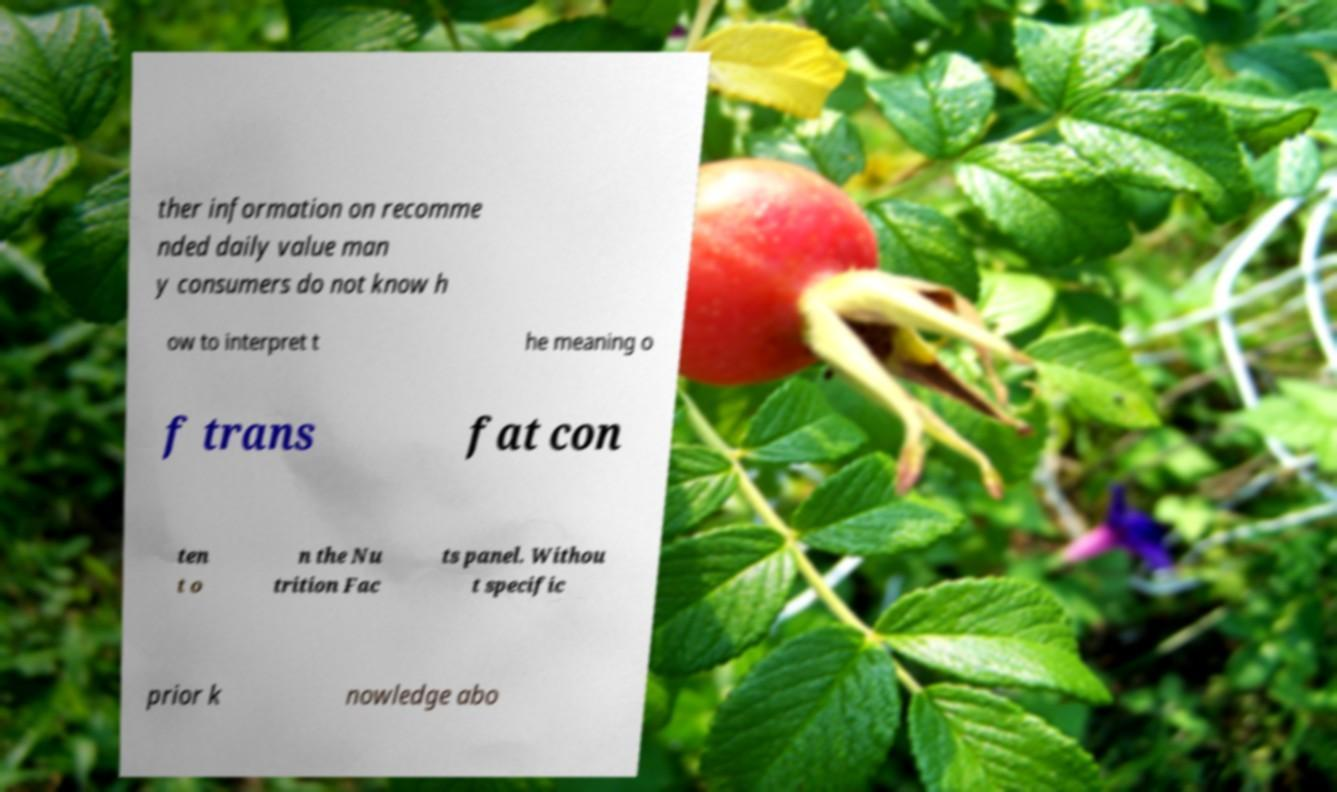Could you assist in decoding the text presented in this image and type it out clearly? ther information on recomme nded daily value man y consumers do not know h ow to interpret t he meaning o f trans fat con ten t o n the Nu trition Fac ts panel. Withou t specific prior k nowledge abo 